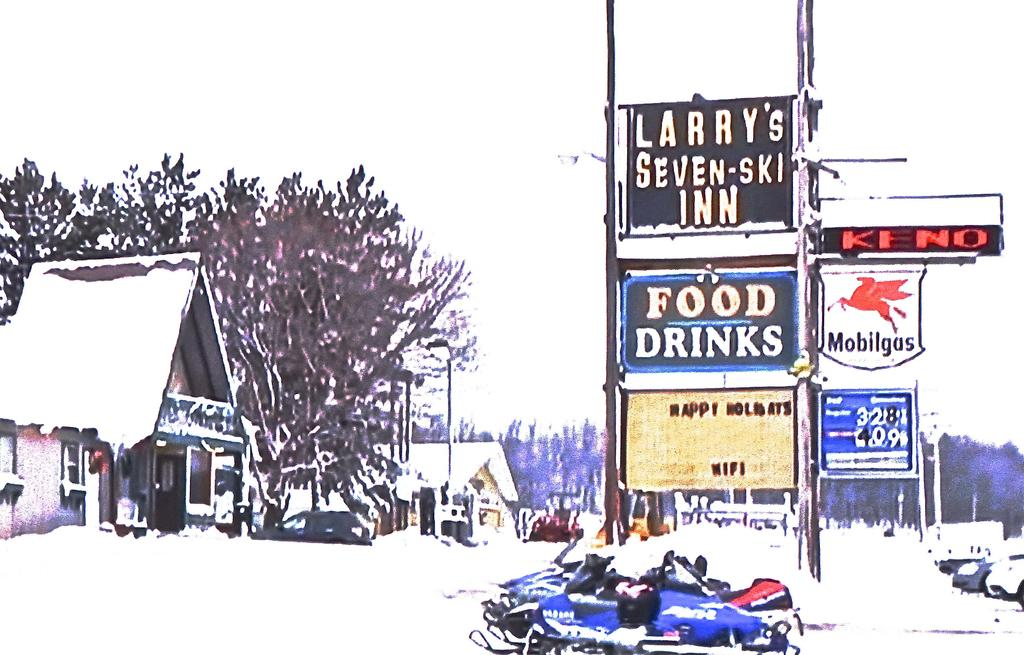What can be seen in the front of the image? There are bikes in the front of the image. What is located in the center of the image? There are boards with text in the center of the image. What type of natural elements are visible in the background of the image? There are trees in the background of the image. What type of man-made structures can be seen in the background of the image? There are houses in the background of the image. What type of quince is being used as a decoration on the bikes in the image? There is no quince present in the image; it features bikes, boards with text, trees, and houses. How many fingers can be seen pointing at the boards with text in the image? There is no mention of fingers or any hand gestures in the image; it only shows bikes, boards with text, trees, and houses. 